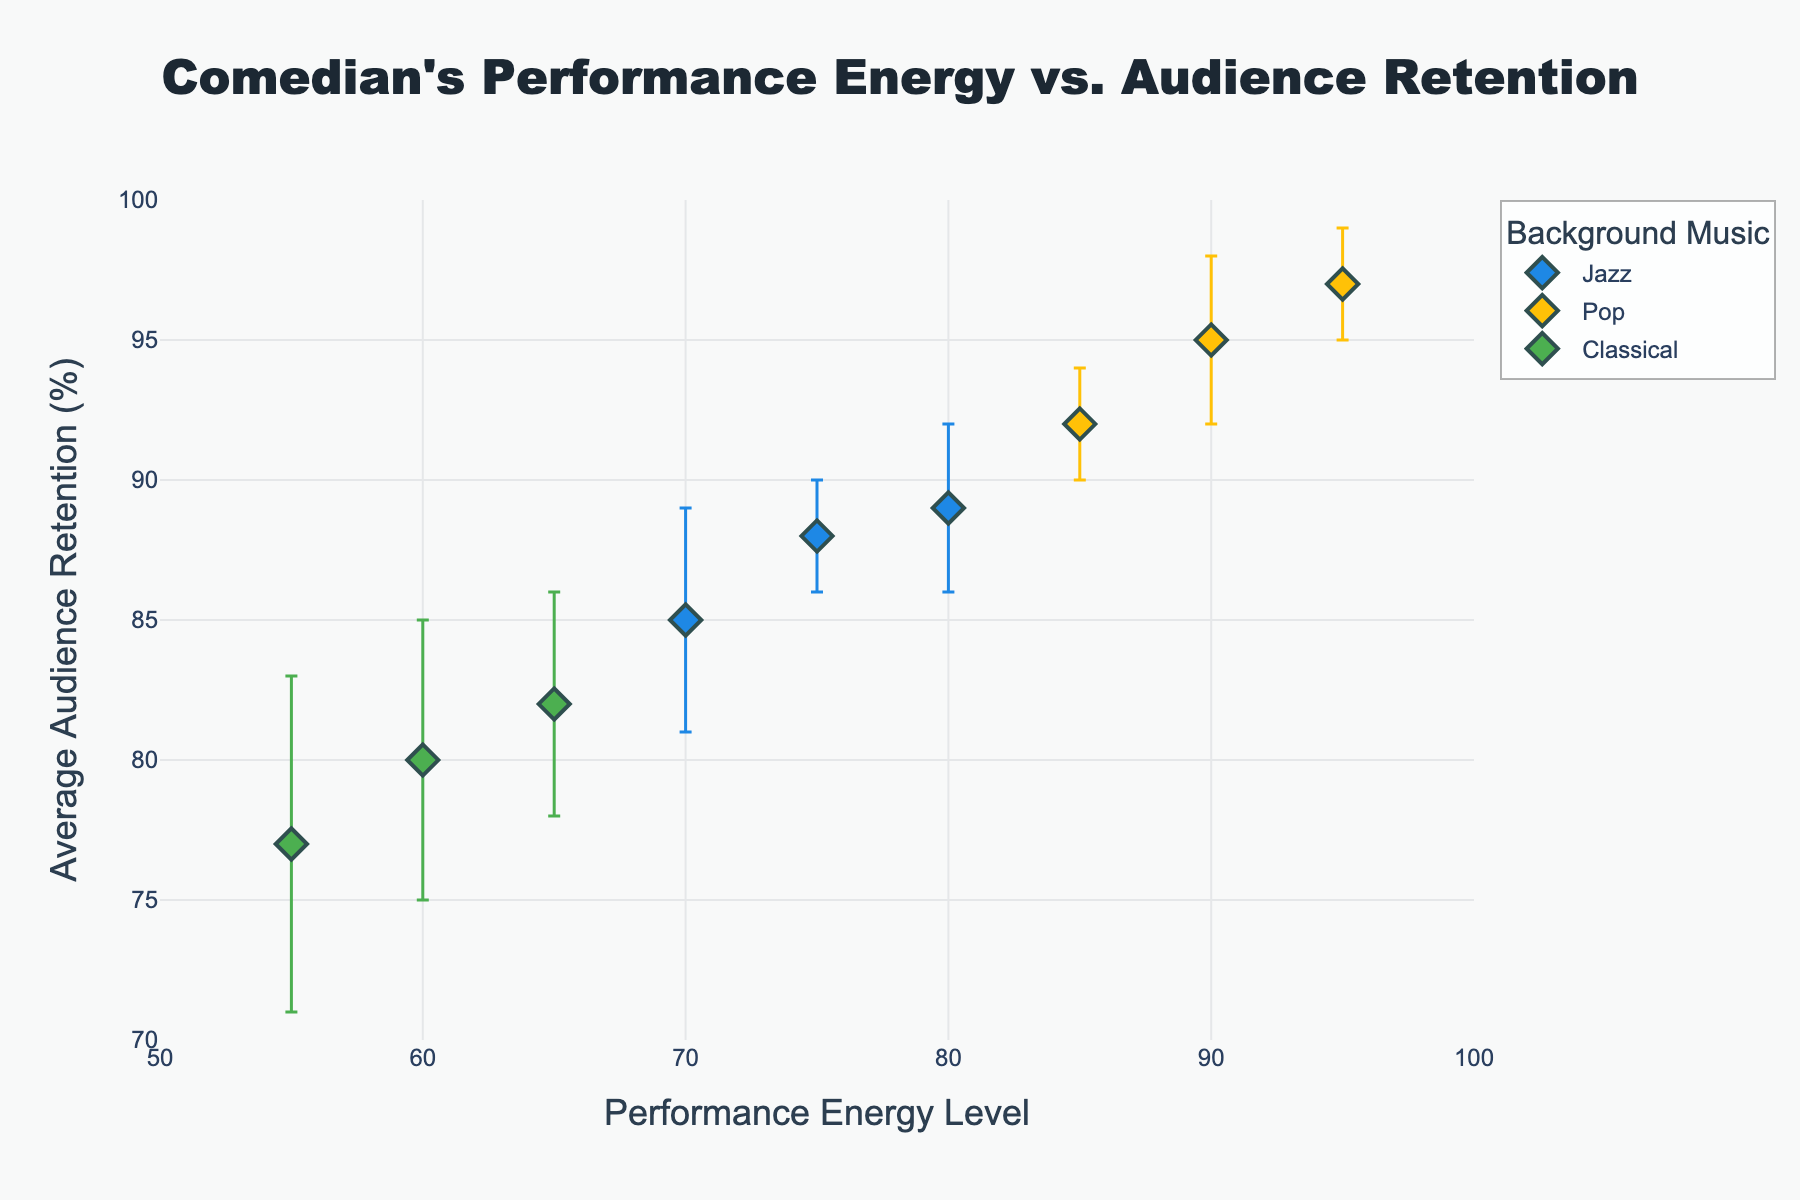What is the title of the figure? The title of the figure is at the top and says, "Comedian's Performance Energy vs. Audience Retention".
Answer: Comedian's Performance Energy vs. Audience Retention How many different types of background music are used in the figure? By looking at the legend on the right side of the plot, there are three types of background music: Jazz, Pop, and Classical.
Answer: 3 Which background music type corresponds to the highest average audience retention? The yellow markers represent Pop music and have the highest average audience retention on the y-axis.
Answer: Pop What is the average audience retention for the performance energy level of 95? The plot shows a yellow marker (Pop) at a performance energy level of 95 with an audience retention value around 97%.
Answer: 97% How does the audience retention for a performance energy level of 85 with Pop music compare to a performance energy level of 80 with Jazz music? The plot shows that Pop music at a performance energy level of 85 has an audience retention of about 92%, while Jazz music at a performance energy level of 80 has an audience retention of about 89%. Thus, Pop has a higher retention at these levels.
Answer: Pop music at 85 has higher retention than Jazz music at 80 What range of performance energy levels is covered by the figure? The x-axis ranges from 50 to 100 as indicated by the axis ticks.
Answer: 50 to 100 Which type of background music shows the highest variability in audience retention? By examining the error bars, Classical music shows the highest variability with some error bars spanning from +/- 5 to +/- 6.
Answer: Classical Which performance energy level has the lowest average audience retention, and what type of music is associated with it? The data point at a performance energy level of 55 (the green marker) has the lowest average audience retention of around 77%, and it is associated with Classical music.
Answer: 55, Classical What is the difference in average audience retention between the highest and lowest energy levels for performances with Jazz background music? The highest energy level for Jazz is 80 with a retention of 89%, and the lowest is 70 with a retention of 85%. The difference is 89% - 85% = 4%.
Answer: 4% 